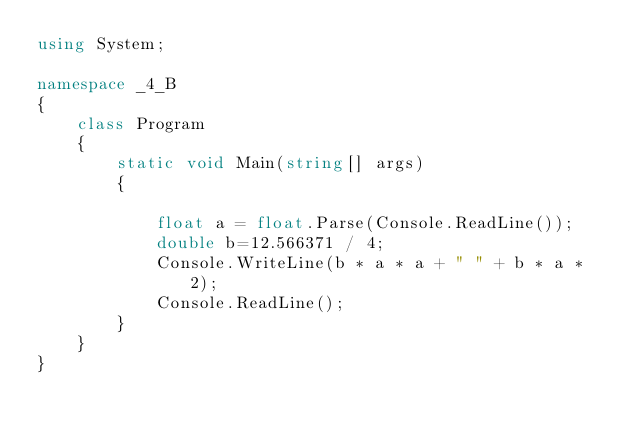<code> <loc_0><loc_0><loc_500><loc_500><_C#_>using System;

namespace _4_B
{
    class Program
    {
        static void Main(string[] args)
        {
           
            float a = float.Parse(Console.ReadLine());
            double b=12.566371 / 4;
            Console.WriteLine(b * a * a + " " + b * a * 2);
            Console.ReadLine();
        }
    }
}</code> 